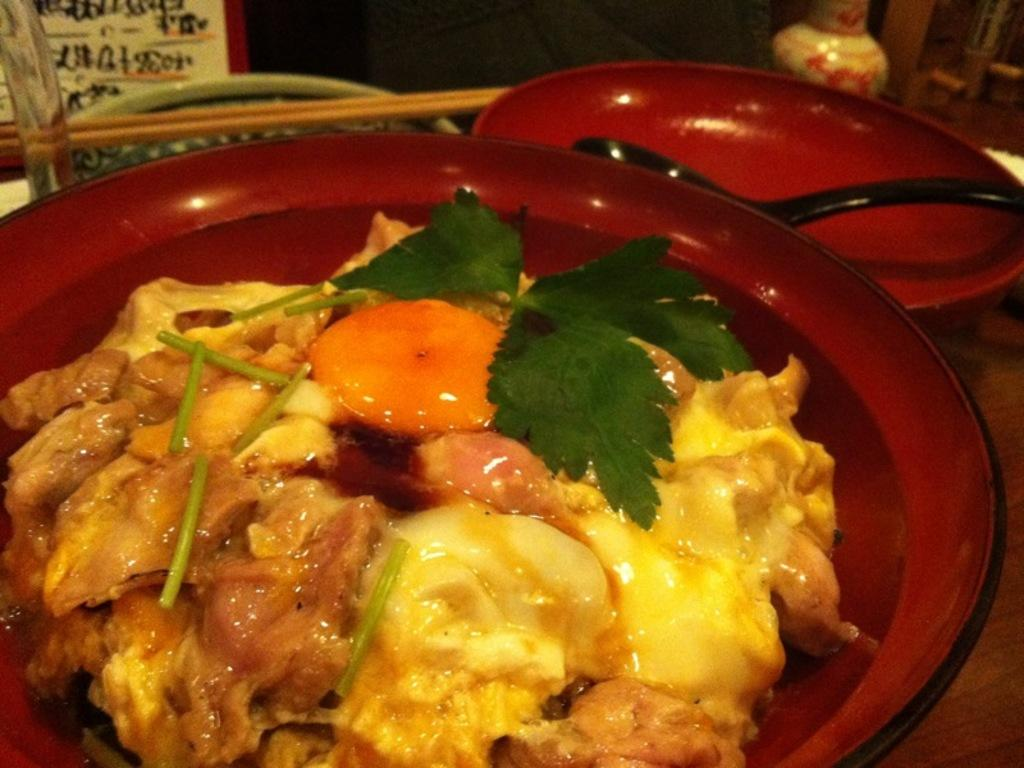What is in the bowl that is visible in the image? There is a food item in the bowl in the image. What other objects can be seen on the table in the image? There is a plate, a spoon, chopsticks, a board, and a vase on the table in the image. What utensils are present in the image? There is a spoon and chopsticks in the image. What type of container is present in the image? There is a vase in the image. What type of bone is visible in the image? There is no bone present in the image. What type of pen is being used to write on the board in the image? There is no pen or writing on the board in the image. 